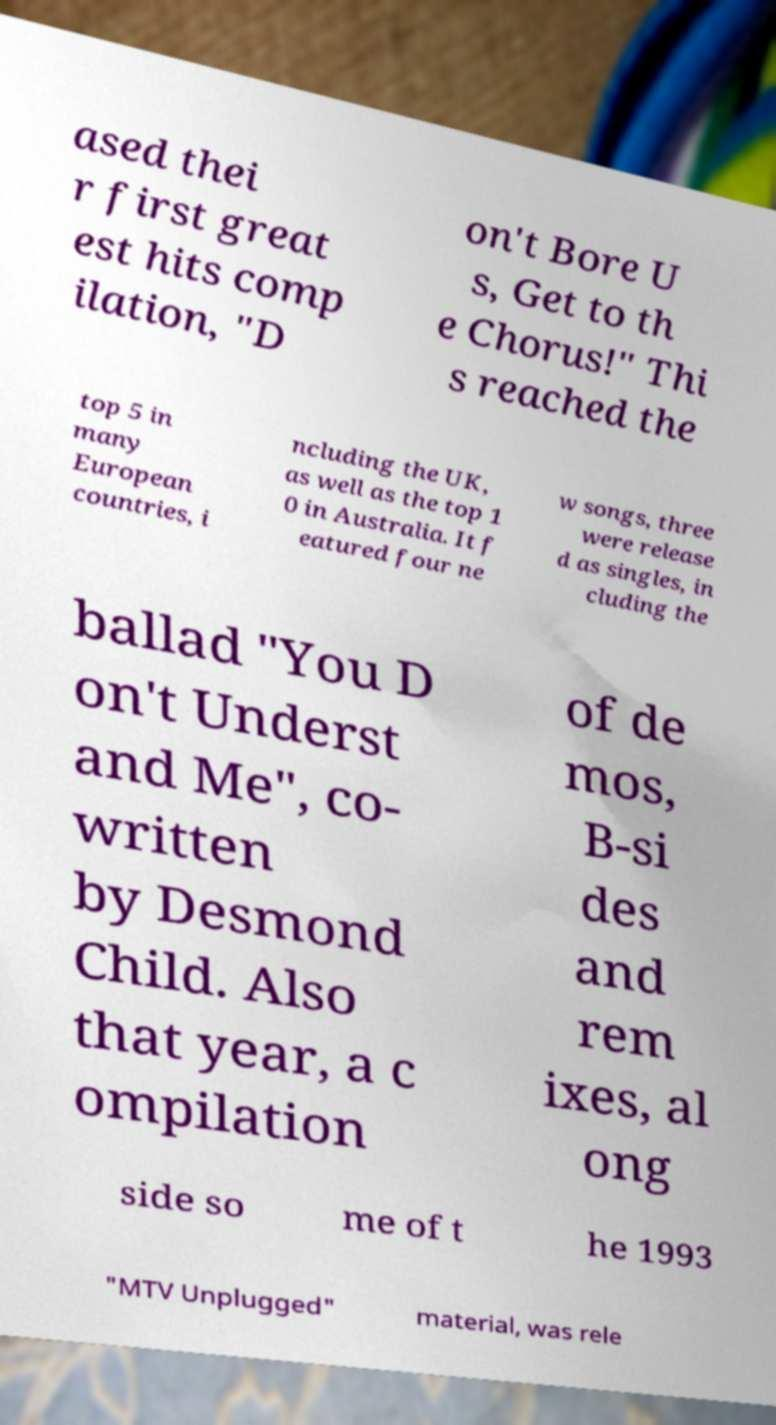I need the written content from this picture converted into text. Can you do that? ased thei r first great est hits comp ilation, "D on't Bore U s, Get to th e Chorus!" Thi s reached the top 5 in many European countries, i ncluding the UK, as well as the top 1 0 in Australia. It f eatured four ne w songs, three were release d as singles, in cluding the ballad "You D on't Underst and Me", co- written by Desmond Child. Also that year, a c ompilation of de mos, B-si des and rem ixes, al ong side so me of t he 1993 "MTV Unplugged" material, was rele 